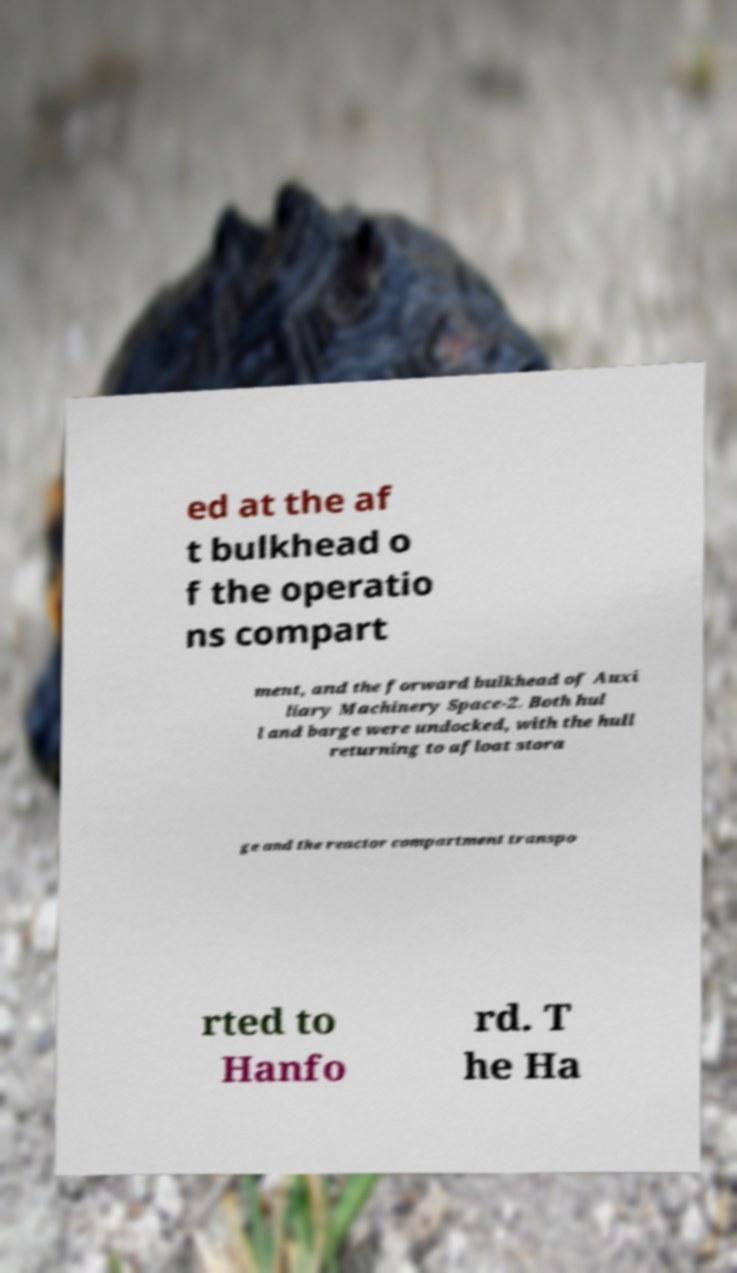For documentation purposes, I need the text within this image transcribed. Could you provide that? ed at the af t bulkhead o f the operatio ns compart ment, and the forward bulkhead of Auxi liary Machinery Space-2. Both hul l and barge were undocked, with the hull returning to afloat stora ge and the reactor compartment transpo rted to Hanfo rd. T he Ha 